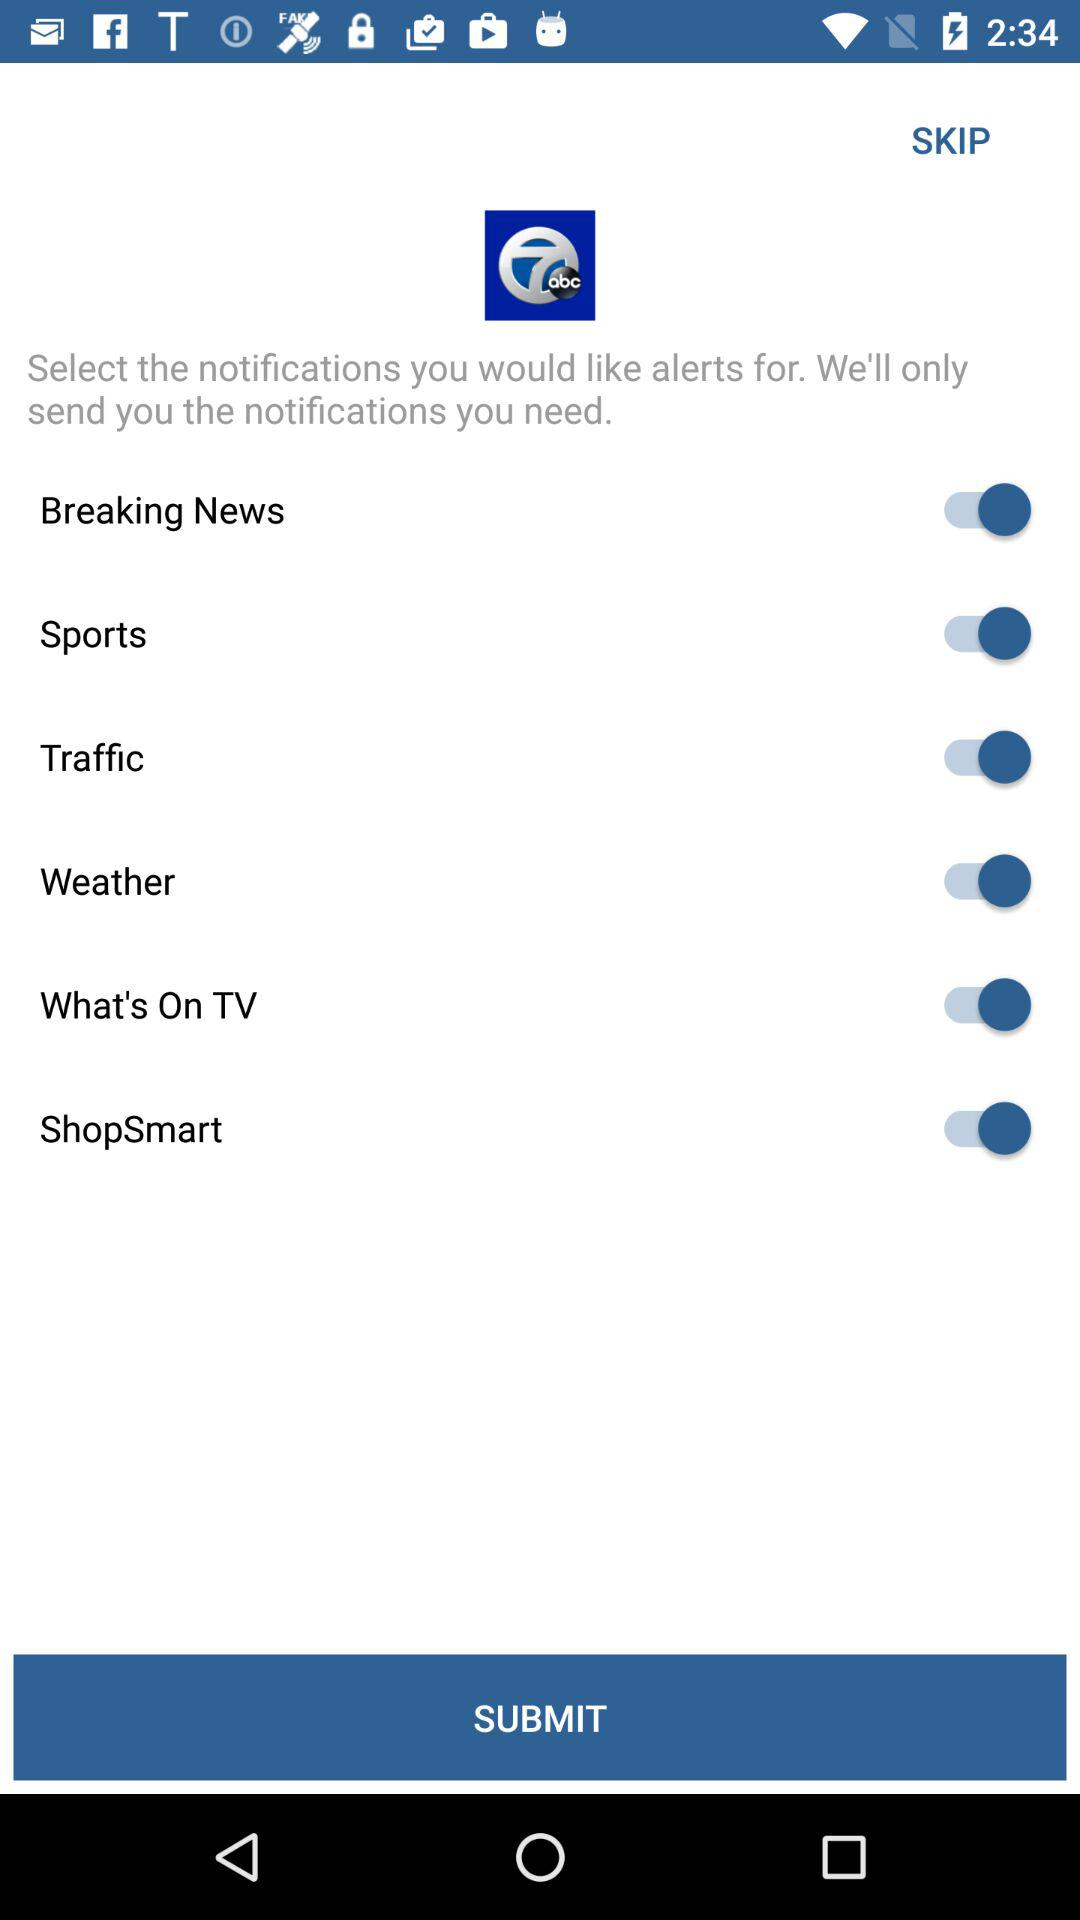How many notifications are available to select?
Answer the question using a single word or phrase. 6 